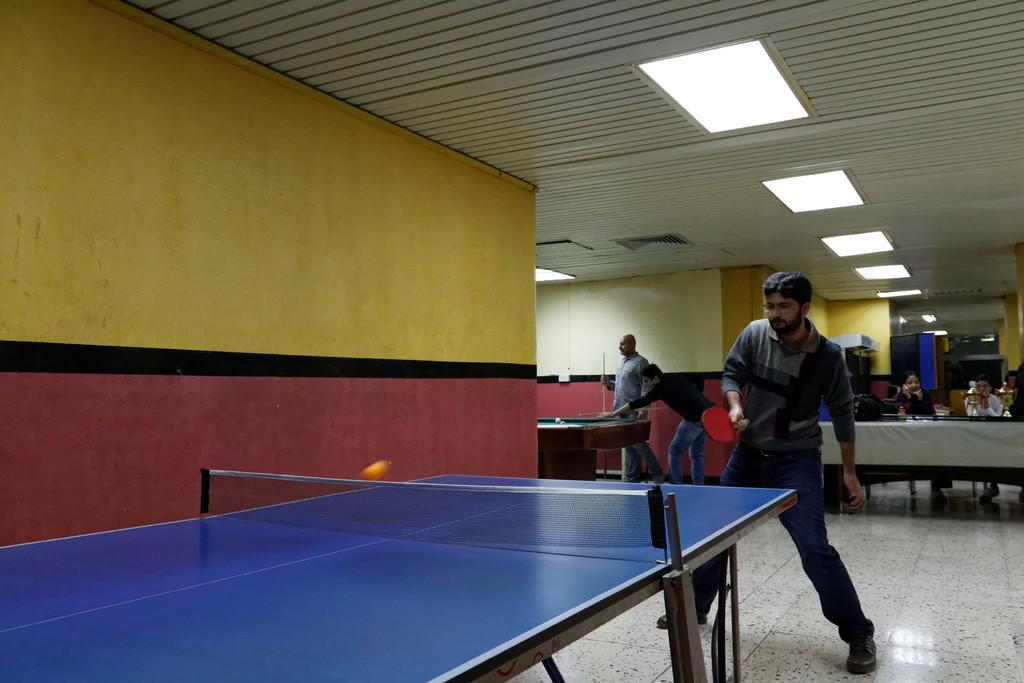In one or two sentences, can you explain what this image depicts? In the picture I can see a person holding table tennis racket in his hand and standing on the floor. Here we can see the blue color table tennis board, net and a ball in the air, we can see the yellow and maroon color wall, we can see a few more people playing the table tennis and these people are sitting on the chairs near the table where trophies are kept and in the background we can see the ceiling lights. 